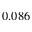Convert formula to latex. <formula><loc_0><loc_0><loc_500><loc_500>0 . 0 8 6</formula> 